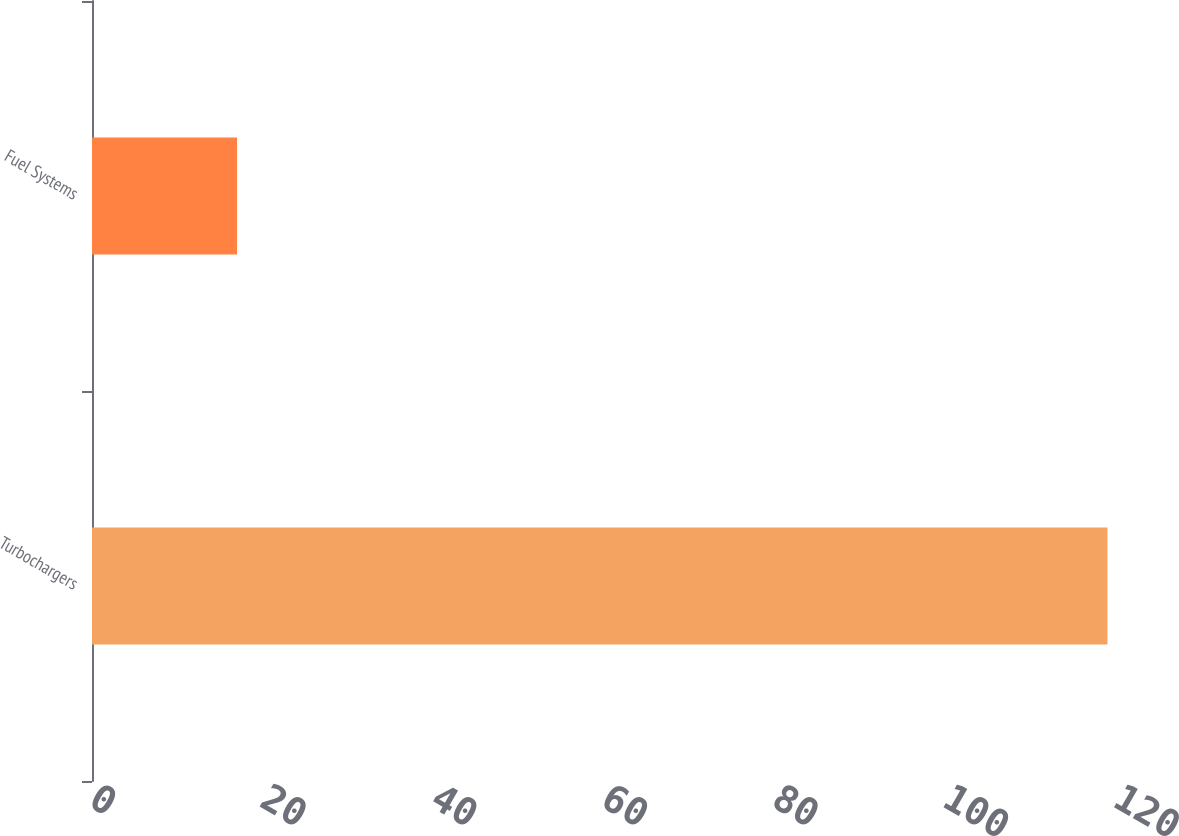Convert chart to OTSL. <chart><loc_0><loc_0><loc_500><loc_500><bar_chart><fcel>Turbochargers<fcel>Fuel Systems<nl><fcel>119<fcel>17<nl></chart> 